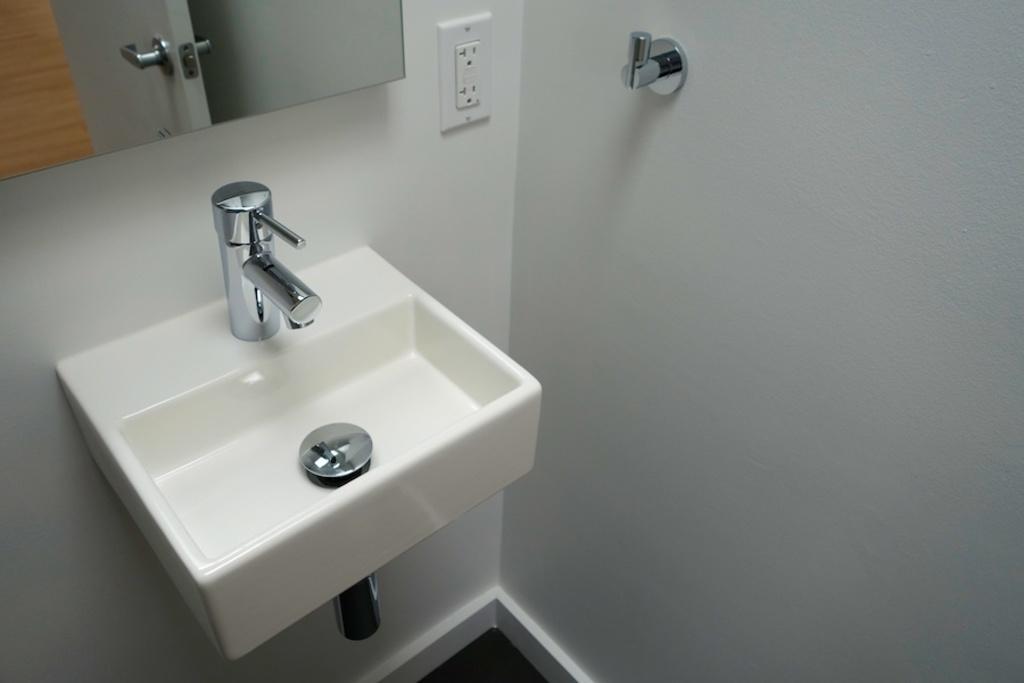Could you give a brief overview of what you see in this image? In this image we can see a wash basin, tap, socket, and an object. There is a wall. Here we can see a mirror. In the mirror we can see the reflection of a door and a holder. 